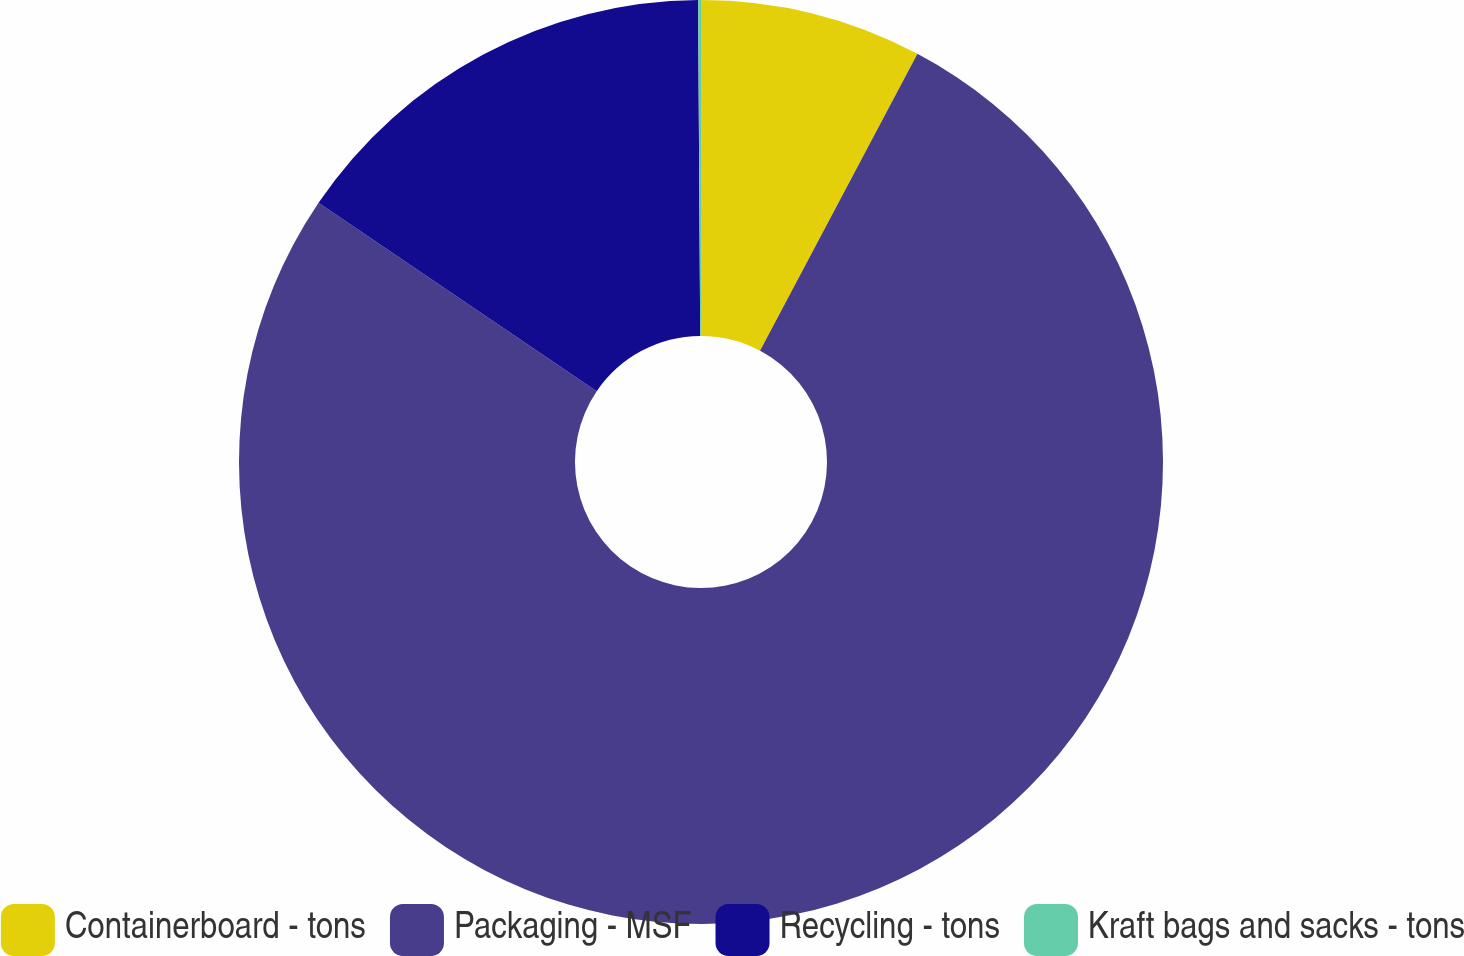Convert chart to OTSL. <chart><loc_0><loc_0><loc_500><loc_500><pie_chart><fcel>Containerboard - tons<fcel>Packaging - MSF<fcel>Recycling - tons<fcel>Kraft bags and sacks - tons<nl><fcel>7.76%<fcel>76.72%<fcel>15.42%<fcel>0.1%<nl></chart> 